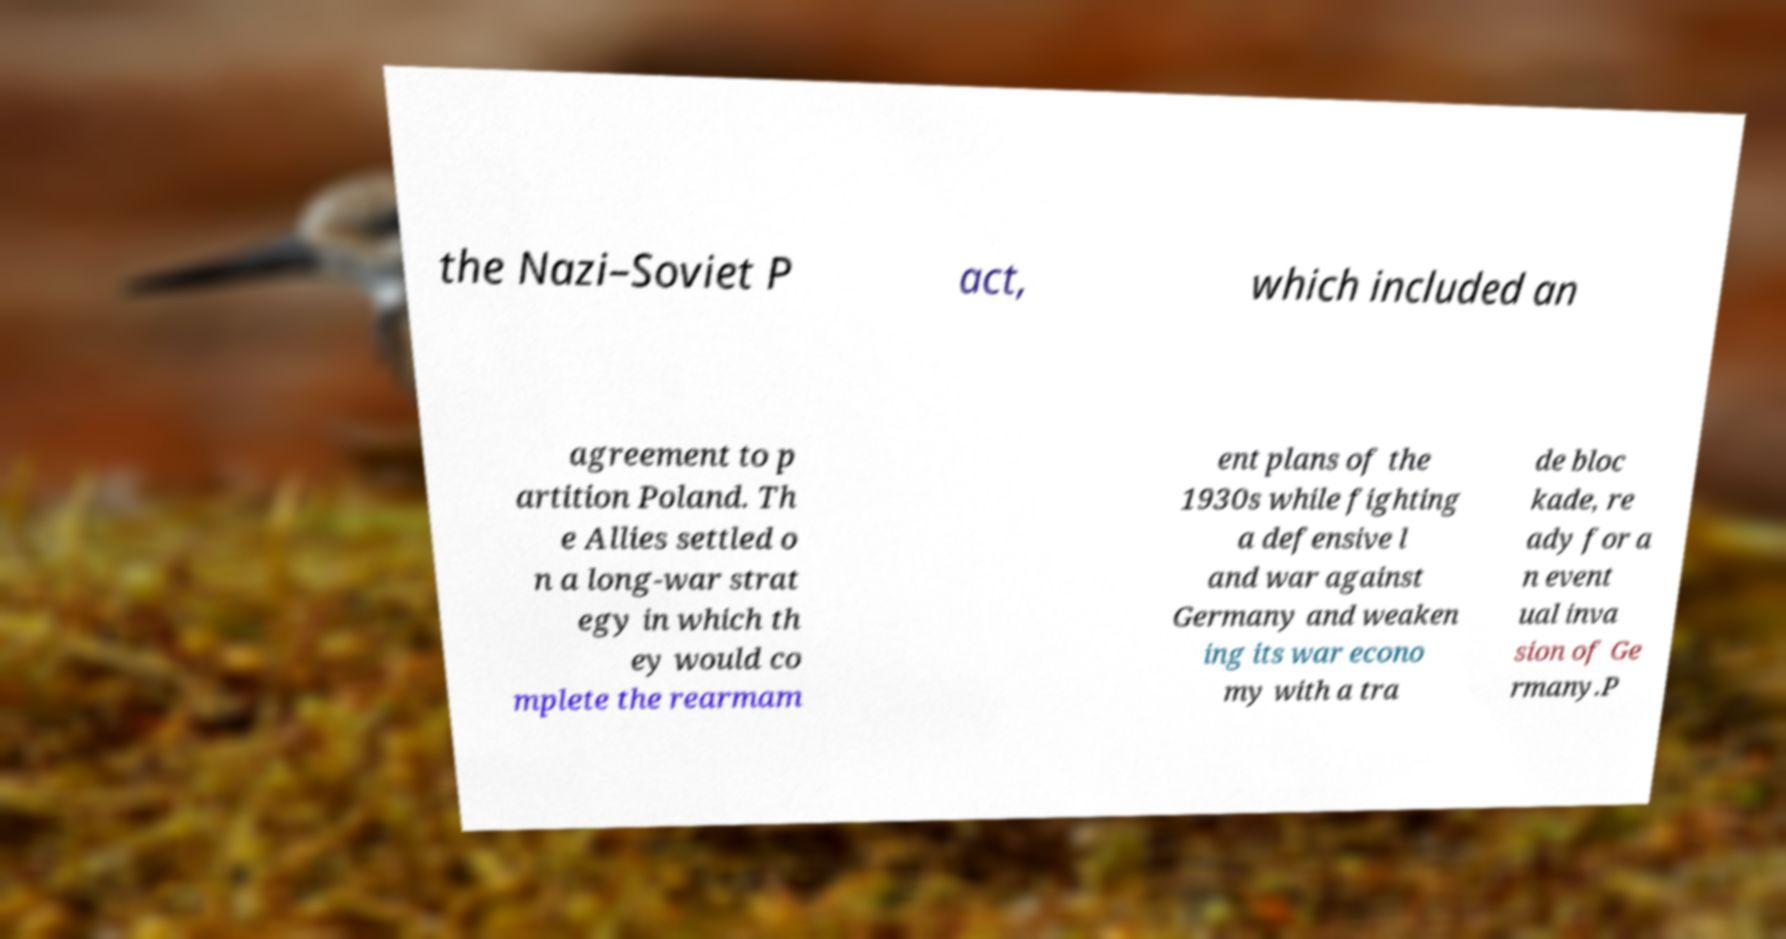What messages or text are displayed in this image? I need them in a readable, typed format. the Nazi–Soviet P act, which included an agreement to p artition Poland. Th e Allies settled o n a long-war strat egy in which th ey would co mplete the rearmam ent plans of the 1930s while fighting a defensive l and war against Germany and weaken ing its war econo my with a tra de bloc kade, re ady for a n event ual inva sion of Ge rmany.P 